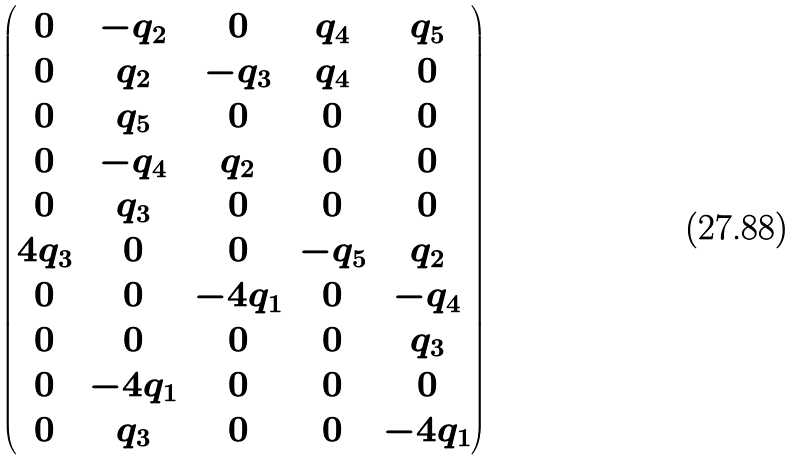Convert formula to latex. <formula><loc_0><loc_0><loc_500><loc_500>\begin{pmatrix} 0 & - q _ { 2 } & 0 & q _ { 4 } & q _ { 5 } \\ 0 & q _ { 2 } & - q _ { 3 } & q _ { 4 } & 0 \\ 0 & q _ { 5 } & 0 & 0 & 0 \\ 0 & - q _ { 4 } & q _ { 2 } & 0 & 0 \\ 0 & q _ { 3 } & 0 & 0 & 0 \\ 4 q _ { 3 } & 0 & 0 & - q _ { 5 } & q _ { 2 } \\ 0 & 0 & - 4 q _ { 1 } & 0 & - q _ { 4 } \\ 0 & 0 & 0 & 0 & q _ { 3 } \\ 0 & - 4 q _ { 1 } & 0 & 0 & 0 \\ 0 & q _ { 3 } & 0 & 0 & - 4 q _ { 1 } \end{pmatrix}</formula> 